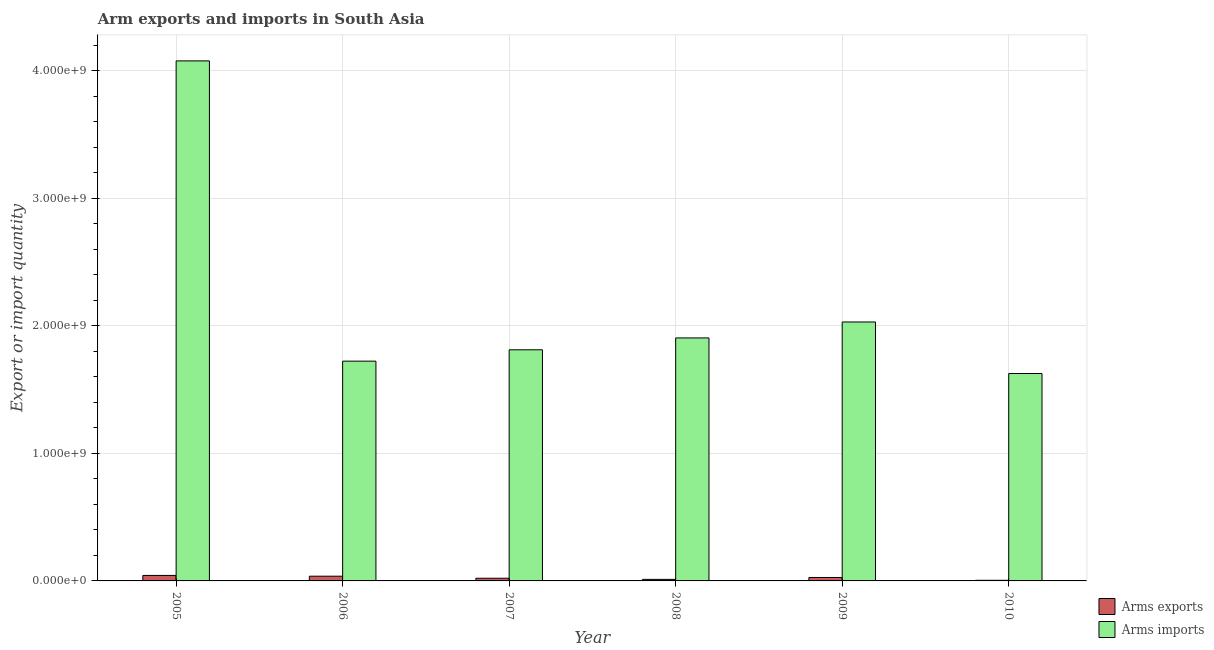Are the number of bars per tick equal to the number of legend labels?
Provide a succinct answer. Yes. Are the number of bars on each tick of the X-axis equal?
Give a very brief answer. Yes. What is the label of the 3rd group of bars from the left?
Your answer should be compact. 2007. In how many cases, is the number of bars for a given year not equal to the number of legend labels?
Make the answer very short. 0. What is the arms exports in 2006?
Offer a terse response. 3.70e+07. Across all years, what is the maximum arms exports?
Offer a terse response. 4.30e+07. Across all years, what is the minimum arms imports?
Give a very brief answer. 1.63e+09. What is the total arms imports in the graph?
Provide a succinct answer. 1.32e+1. What is the difference between the arms exports in 2005 and that in 2009?
Offer a very short reply. 1.60e+07. What is the difference between the arms imports in 2005 and the arms exports in 2010?
Make the answer very short. 2.45e+09. What is the average arms exports per year?
Ensure brevity in your answer.  2.42e+07. What is the ratio of the arms imports in 2006 to that in 2009?
Your answer should be very brief. 0.85. Is the arms imports in 2005 less than that in 2007?
Your response must be concise. No. Is the difference between the arms exports in 2005 and 2008 greater than the difference between the arms imports in 2005 and 2008?
Offer a terse response. No. What is the difference between the highest and the second highest arms imports?
Your answer should be compact. 2.05e+09. What is the difference between the highest and the lowest arms exports?
Offer a very short reply. 3.80e+07. In how many years, is the arms imports greater than the average arms imports taken over all years?
Offer a terse response. 1. Is the sum of the arms exports in 2006 and 2008 greater than the maximum arms imports across all years?
Provide a succinct answer. Yes. What does the 2nd bar from the left in 2007 represents?
Your answer should be compact. Arms imports. What does the 2nd bar from the right in 2006 represents?
Give a very brief answer. Arms exports. How many bars are there?
Your answer should be compact. 12. How many years are there in the graph?
Offer a very short reply. 6. What is the difference between two consecutive major ticks on the Y-axis?
Offer a terse response. 1.00e+09. Are the values on the major ticks of Y-axis written in scientific E-notation?
Provide a short and direct response. Yes. Where does the legend appear in the graph?
Keep it short and to the point. Bottom right. How many legend labels are there?
Keep it short and to the point. 2. What is the title of the graph?
Your answer should be compact. Arm exports and imports in South Asia. Does "Register a business" appear as one of the legend labels in the graph?
Your answer should be very brief. No. What is the label or title of the X-axis?
Keep it short and to the point. Year. What is the label or title of the Y-axis?
Your response must be concise. Export or import quantity. What is the Export or import quantity in Arms exports in 2005?
Offer a very short reply. 4.30e+07. What is the Export or import quantity in Arms imports in 2005?
Your answer should be very brief. 4.08e+09. What is the Export or import quantity of Arms exports in 2006?
Make the answer very short. 3.70e+07. What is the Export or import quantity in Arms imports in 2006?
Provide a succinct answer. 1.72e+09. What is the Export or import quantity in Arms exports in 2007?
Make the answer very short. 2.10e+07. What is the Export or import quantity in Arms imports in 2007?
Provide a short and direct response. 1.81e+09. What is the Export or import quantity in Arms exports in 2008?
Offer a very short reply. 1.20e+07. What is the Export or import quantity of Arms imports in 2008?
Ensure brevity in your answer.  1.90e+09. What is the Export or import quantity of Arms exports in 2009?
Give a very brief answer. 2.70e+07. What is the Export or import quantity of Arms imports in 2009?
Your response must be concise. 2.03e+09. What is the Export or import quantity in Arms exports in 2010?
Your answer should be very brief. 5.00e+06. What is the Export or import quantity in Arms imports in 2010?
Provide a short and direct response. 1.63e+09. Across all years, what is the maximum Export or import quantity of Arms exports?
Make the answer very short. 4.30e+07. Across all years, what is the maximum Export or import quantity in Arms imports?
Your answer should be very brief. 4.08e+09. Across all years, what is the minimum Export or import quantity in Arms imports?
Your answer should be compact. 1.63e+09. What is the total Export or import quantity in Arms exports in the graph?
Keep it short and to the point. 1.45e+08. What is the total Export or import quantity in Arms imports in the graph?
Make the answer very short. 1.32e+1. What is the difference between the Export or import quantity of Arms exports in 2005 and that in 2006?
Your answer should be very brief. 6.00e+06. What is the difference between the Export or import quantity of Arms imports in 2005 and that in 2006?
Keep it short and to the point. 2.35e+09. What is the difference between the Export or import quantity in Arms exports in 2005 and that in 2007?
Offer a terse response. 2.20e+07. What is the difference between the Export or import quantity of Arms imports in 2005 and that in 2007?
Ensure brevity in your answer.  2.26e+09. What is the difference between the Export or import quantity in Arms exports in 2005 and that in 2008?
Keep it short and to the point. 3.10e+07. What is the difference between the Export or import quantity of Arms imports in 2005 and that in 2008?
Provide a succinct answer. 2.17e+09. What is the difference between the Export or import quantity of Arms exports in 2005 and that in 2009?
Your response must be concise. 1.60e+07. What is the difference between the Export or import quantity in Arms imports in 2005 and that in 2009?
Offer a very short reply. 2.05e+09. What is the difference between the Export or import quantity in Arms exports in 2005 and that in 2010?
Your response must be concise. 3.80e+07. What is the difference between the Export or import quantity in Arms imports in 2005 and that in 2010?
Offer a terse response. 2.45e+09. What is the difference between the Export or import quantity in Arms exports in 2006 and that in 2007?
Provide a succinct answer. 1.60e+07. What is the difference between the Export or import quantity of Arms imports in 2006 and that in 2007?
Provide a succinct answer. -8.90e+07. What is the difference between the Export or import quantity of Arms exports in 2006 and that in 2008?
Provide a succinct answer. 2.50e+07. What is the difference between the Export or import quantity of Arms imports in 2006 and that in 2008?
Offer a terse response. -1.82e+08. What is the difference between the Export or import quantity of Arms imports in 2006 and that in 2009?
Offer a terse response. -3.07e+08. What is the difference between the Export or import quantity of Arms exports in 2006 and that in 2010?
Your answer should be very brief. 3.20e+07. What is the difference between the Export or import quantity of Arms imports in 2006 and that in 2010?
Give a very brief answer. 9.70e+07. What is the difference between the Export or import quantity in Arms exports in 2007 and that in 2008?
Make the answer very short. 9.00e+06. What is the difference between the Export or import quantity in Arms imports in 2007 and that in 2008?
Give a very brief answer. -9.30e+07. What is the difference between the Export or import quantity in Arms exports in 2007 and that in 2009?
Make the answer very short. -6.00e+06. What is the difference between the Export or import quantity of Arms imports in 2007 and that in 2009?
Provide a short and direct response. -2.18e+08. What is the difference between the Export or import quantity of Arms exports in 2007 and that in 2010?
Give a very brief answer. 1.60e+07. What is the difference between the Export or import quantity of Arms imports in 2007 and that in 2010?
Ensure brevity in your answer.  1.86e+08. What is the difference between the Export or import quantity of Arms exports in 2008 and that in 2009?
Your response must be concise. -1.50e+07. What is the difference between the Export or import quantity in Arms imports in 2008 and that in 2009?
Your answer should be very brief. -1.25e+08. What is the difference between the Export or import quantity in Arms imports in 2008 and that in 2010?
Provide a short and direct response. 2.79e+08. What is the difference between the Export or import quantity in Arms exports in 2009 and that in 2010?
Ensure brevity in your answer.  2.20e+07. What is the difference between the Export or import quantity in Arms imports in 2009 and that in 2010?
Your response must be concise. 4.04e+08. What is the difference between the Export or import quantity of Arms exports in 2005 and the Export or import quantity of Arms imports in 2006?
Give a very brief answer. -1.68e+09. What is the difference between the Export or import quantity of Arms exports in 2005 and the Export or import quantity of Arms imports in 2007?
Offer a terse response. -1.77e+09. What is the difference between the Export or import quantity in Arms exports in 2005 and the Export or import quantity in Arms imports in 2008?
Offer a terse response. -1.86e+09. What is the difference between the Export or import quantity of Arms exports in 2005 and the Export or import quantity of Arms imports in 2009?
Your answer should be compact. -1.99e+09. What is the difference between the Export or import quantity in Arms exports in 2005 and the Export or import quantity in Arms imports in 2010?
Keep it short and to the point. -1.58e+09. What is the difference between the Export or import quantity in Arms exports in 2006 and the Export or import quantity in Arms imports in 2007?
Offer a terse response. -1.78e+09. What is the difference between the Export or import quantity of Arms exports in 2006 and the Export or import quantity of Arms imports in 2008?
Your response must be concise. -1.87e+09. What is the difference between the Export or import quantity of Arms exports in 2006 and the Export or import quantity of Arms imports in 2009?
Provide a short and direct response. -1.99e+09. What is the difference between the Export or import quantity in Arms exports in 2006 and the Export or import quantity in Arms imports in 2010?
Provide a short and direct response. -1.59e+09. What is the difference between the Export or import quantity in Arms exports in 2007 and the Export or import quantity in Arms imports in 2008?
Offer a terse response. -1.88e+09. What is the difference between the Export or import quantity of Arms exports in 2007 and the Export or import quantity of Arms imports in 2009?
Your response must be concise. -2.01e+09. What is the difference between the Export or import quantity of Arms exports in 2007 and the Export or import quantity of Arms imports in 2010?
Make the answer very short. -1.60e+09. What is the difference between the Export or import quantity in Arms exports in 2008 and the Export or import quantity in Arms imports in 2009?
Offer a very short reply. -2.02e+09. What is the difference between the Export or import quantity in Arms exports in 2008 and the Export or import quantity in Arms imports in 2010?
Give a very brief answer. -1.61e+09. What is the difference between the Export or import quantity of Arms exports in 2009 and the Export or import quantity of Arms imports in 2010?
Make the answer very short. -1.60e+09. What is the average Export or import quantity in Arms exports per year?
Offer a terse response. 2.42e+07. What is the average Export or import quantity in Arms imports per year?
Ensure brevity in your answer.  2.20e+09. In the year 2005, what is the difference between the Export or import quantity in Arms exports and Export or import quantity in Arms imports?
Give a very brief answer. -4.03e+09. In the year 2006, what is the difference between the Export or import quantity in Arms exports and Export or import quantity in Arms imports?
Your response must be concise. -1.69e+09. In the year 2007, what is the difference between the Export or import quantity in Arms exports and Export or import quantity in Arms imports?
Ensure brevity in your answer.  -1.79e+09. In the year 2008, what is the difference between the Export or import quantity of Arms exports and Export or import quantity of Arms imports?
Offer a very short reply. -1.89e+09. In the year 2009, what is the difference between the Export or import quantity in Arms exports and Export or import quantity in Arms imports?
Provide a succinct answer. -2.00e+09. In the year 2010, what is the difference between the Export or import quantity of Arms exports and Export or import quantity of Arms imports?
Your response must be concise. -1.62e+09. What is the ratio of the Export or import quantity in Arms exports in 2005 to that in 2006?
Keep it short and to the point. 1.16. What is the ratio of the Export or import quantity of Arms imports in 2005 to that in 2006?
Keep it short and to the point. 2.37. What is the ratio of the Export or import quantity of Arms exports in 2005 to that in 2007?
Make the answer very short. 2.05. What is the ratio of the Export or import quantity of Arms imports in 2005 to that in 2007?
Give a very brief answer. 2.25. What is the ratio of the Export or import quantity of Arms exports in 2005 to that in 2008?
Provide a succinct answer. 3.58. What is the ratio of the Export or import quantity in Arms imports in 2005 to that in 2008?
Offer a very short reply. 2.14. What is the ratio of the Export or import quantity in Arms exports in 2005 to that in 2009?
Your answer should be very brief. 1.59. What is the ratio of the Export or import quantity in Arms imports in 2005 to that in 2009?
Your answer should be very brief. 2.01. What is the ratio of the Export or import quantity in Arms imports in 2005 to that in 2010?
Make the answer very short. 2.51. What is the ratio of the Export or import quantity of Arms exports in 2006 to that in 2007?
Provide a succinct answer. 1.76. What is the ratio of the Export or import quantity of Arms imports in 2006 to that in 2007?
Your answer should be very brief. 0.95. What is the ratio of the Export or import quantity of Arms exports in 2006 to that in 2008?
Provide a succinct answer. 3.08. What is the ratio of the Export or import quantity of Arms imports in 2006 to that in 2008?
Your answer should be compact. 0.9. What is the ratio of the Export or import quantity of Arms exports in 2006 to that in 2009?
Your answer should be compact. 1.37. What is the ratio of the Export or import quantity in Arms imports in 2006 to that in 2009?
Give a very brief answer. 0.85. What is the ratio of the Export or import quantity in Arms exports in 2006 to that in 2010?
Offer a terse response. 7.4. What is the ratio of the Export or import quantity in Arms imports in 2006 to that in 2010?
Keep it short and to the point. 1.06. What is the ratio of the Export or import quantity in Arms exports in 2007 to that in 2008?
Provide a succinct answer. 1.75. What is the ratio of the Export or import quantity of Arms imports in 2007 to that in 2008?
Ensure brevity in your answer.  0.95. What is the ratio of the Export or import quantity of Arms exports in 2007 to that in 2009?
Your answer should be very brief. 0.78. What is the ratio of the Export or import quantity of Arms imports in 2007 to that in 2009?
Your response must be concise. 0.89. What is the ratio of the Export or import quantity in Arms imports in 2007 to that in 2010?
Provide a succinct answer. 1.11. What is the ratio of the Export or import quantity of Arms exports in 2008 to that in 2009?
Provide a short and direct response. 0.44. What is the ratio of the Export or import quantity in Arms imports in 2008 to that in 2009?
Keep it short and to the point. 0.94. What is the ratio of the Export or import quantity in Arms exports in 2008 to that in 2010?
Provide a succinct answer. 2.4. What is the ratio of the Export or import quantity in Arms imports in 2008 to that in 2010?
Provide a short and direct response. 1.17. What is the ratio of the Export or import quantity in Arms imports in 2009 to that in 2010?
Keep it short and to the point. 1.25. What is the difference between the highest and the second highest Export or import quantity of Arms imports?
Give a very brief answer. 2.05e+09. What is the difference between the highest and the lowest Export or import quantity of Arms exports?
Your answer should be compact. 3.80e+07. What is the difference between the highest and the lowest Export or import quantity in Arms imports?
Offer a terse response. 2.45e+09. 